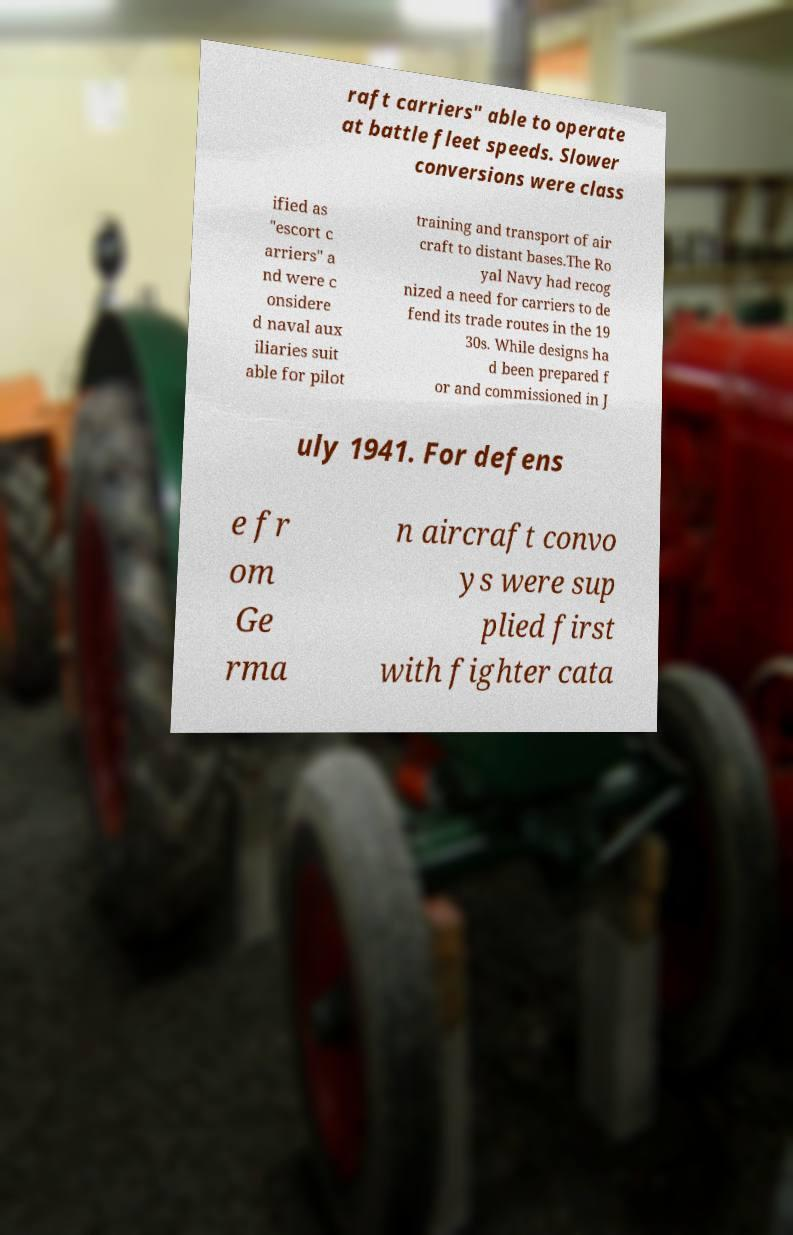There's text embedded in this image that I need extracted. Can you transcribe it verbatim? raft carriers" able to operate at battle fleet speeds. Slower conversions were class ified as "escort c arriers" a nd were c onsidere d naval aux iliaries suit able for pilot training and transport of air craft to distant bases.The Ro yal Navy had recog nized a need for carriers to de fend its trade routes in the 19 30s. While designs ha d been prepared f or and commissioned in J uly 1941. For defens e fr om Ge rma n aircraft convo ys were sup plied first with fighter cata 